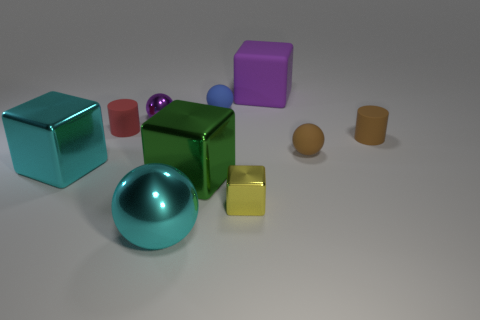Subtract all cylinders. How many objects are left? 8 Add 1 small brown cylinders. How many small brown cylinders are left? 2 Add 8 yellow metallic cubes. How many yellow metallic cubes exist? 9 Subtract 1 red cylinders. How many objects are left? 9 Subtract all big objects. Subtract all tiny rubber cylinders. How many objects are left? 4 